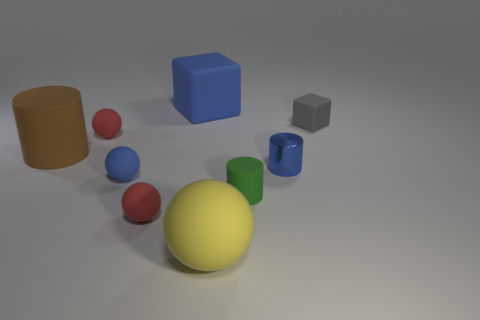How many shiny things are either large blue objects or gray cubes?
Provide a short and direct response. 0. What color is the other rubber thing that is the same shape as the brown rubber thing?
Make the answer very short. Green. Are there any big purple rubber cylinders?
Provide a short and direct response. No. Are the small blue object that is on the right side of the yellow object and the small red thing in front of the small green cylinder made of the same material?
Your answer should be compact. No. The tiny matte object that is the same color as the tiny metallic object is what shape?
Your response must be concise. Sphere. What number of objects are either blue rubber things that are on the left side of the blue rubber cube or cylinders on the right side of the big yellow rubber sphere?
Give a very brief answer. 3. Does the small matte cylinder right of the big block have the same color as the cylinder behind the metallic object?
Your response must be concise. No. What is the shape of the big matte object that is in front of the gray block and behind the green matte object?
Your response must be concise. Cylinder. What is the color of the block that is the same size as the metallic thing?
Offer a very short reply. Gray. Is there a tiny rubber cylinder of the same color as the big rubber sphere?
Keep it short and to the point. No. 